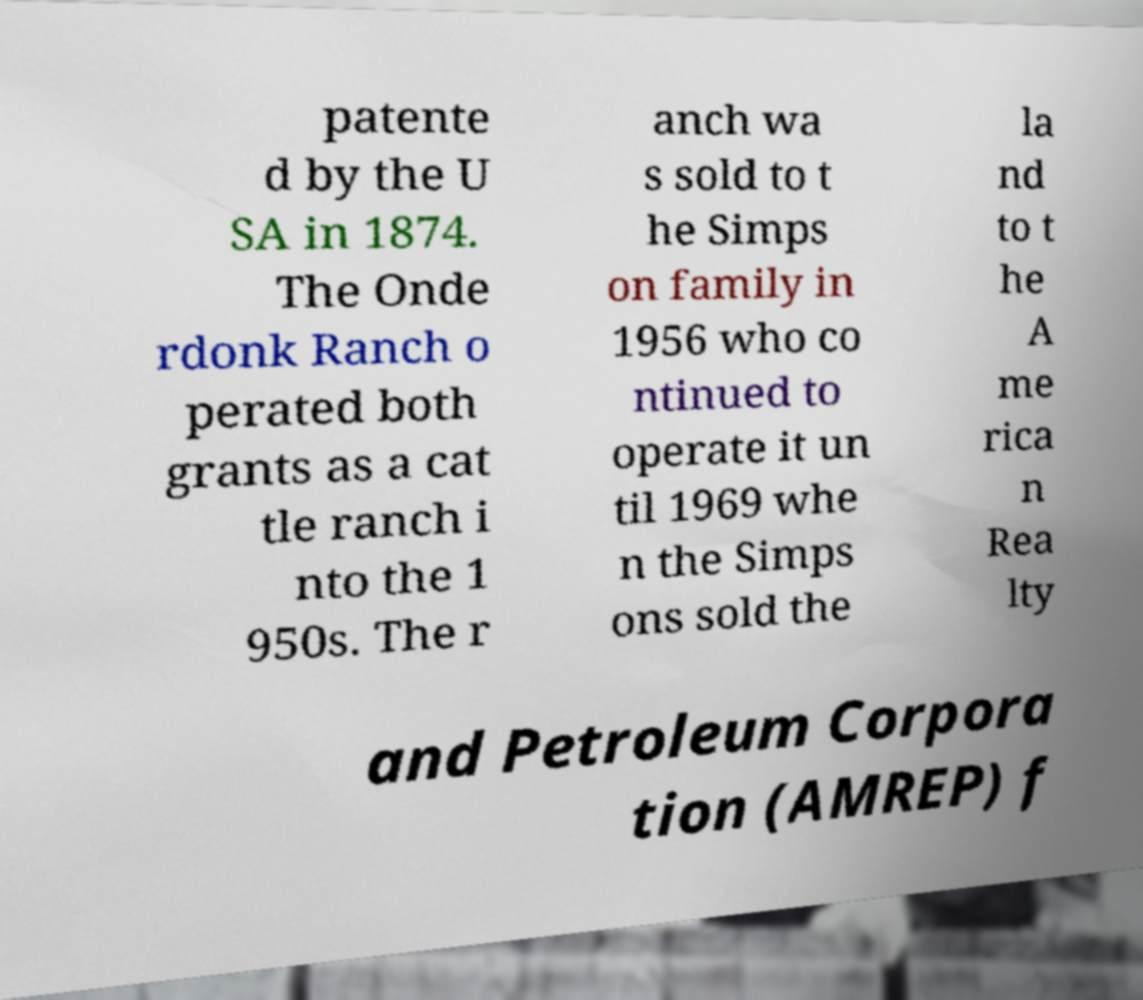Could you assist in decoding the text presented in this image and type it out clearly? patente d by the U SA in 1874. The Onde rdonk Ranch o perated both grants as a cat tle ranch i nto the 1 950s. The r anch wa s sold to t he Simps on family in 1956 who co ntinued to operate it un til 1969 whe n the Simps ons sold the la nd to t he A me rica n Rea lty and Petroleum Corpora tion (AMREP) f 